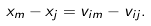<formula> <loc_0><loc_0><loc_500><loc_500>x _ { m } - x _ { j } = v _ { i m } - v _ { i j } .</formula> 